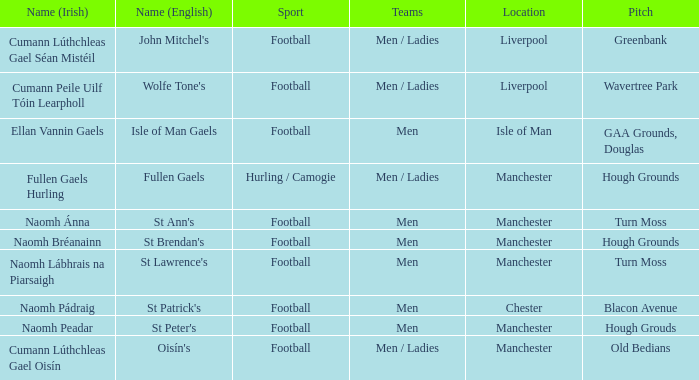Help me parse the entirety of this table. {'header': ['Name (Irish)', 'Name (English)', 'Sport', 'Teams', 'Location', 'Pitch'], 'rows': [['Cumann Lúthchleas Gael Séan Mistéil', "John Mitchel's", 'Football', 'Men / Ladies', 'Liverpool', 'Greenbank'], ['Cumann Peile Uilf Tóin Learpholl', "Wolfe Tone's", 'Football', 'Men / Ladies', 'Liverpool', 'Wavertree Park'], ['Ellan Vannin Gaels', 'Isle of Man Gaels', 'Football', 'Men', 'Isle of Man', 'GAA Grounds, Douglas'], ['Fullen Gaels Hurling', 'Fullen Gaels', 'Hurling / Camogie', 'Men / Ladies', 'Manchester', 'Hough Grounds'], ['Naomh Ánna', "St Ann's", 'Football', 'Men', 'Manchester', 'Turn Moss'], ['Naomh Bréanainn', "St Brendan's", 'Football', 'Men', 'Manchester', 'Hough Grounds'], ['Naomh Lábhrais na Piarsaigh', "St Lawrence's", 'Football', 'Men', 'Manchester', 'Turn Moss'], ['Naomh Pádraig', "St Patrick's", 'Football', 'Men', 'Chester', 'Blacon Avenue'], ['Naomh Peadar', "St Peter's", 'Football', 'Men', 'Manchester', 'Hough Grouds'], ['Cumann Lúthchleas Gael Oisín', "Oisín's", 'Football', 'Men / Ladies', 'Manchester', 'Old Bedians']]} Can you provide the address of the old bedians pitch? Manchester. 